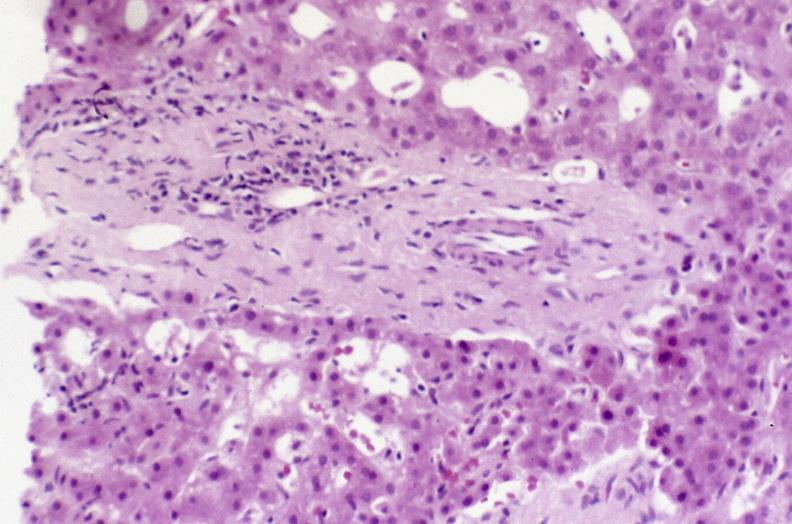what is present?
Answer the question using a single word or phrase. Hepatobiliary 